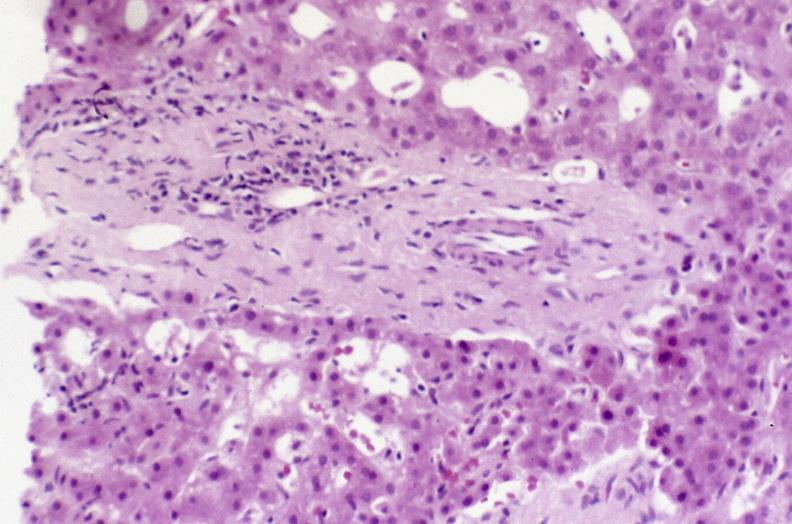what is present?
Answer the question using a single word or phrase. Hepatobiliary 